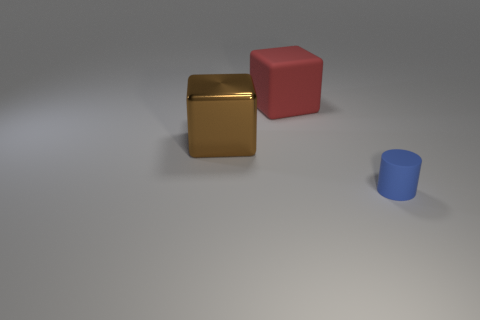Subtract all red blocks. How many blocks are left? 1 Add 2 big things. How many objects exist? 5 Add 2 big red matte blocks. How many big red matte blocks are left? 3 Add 1 yellow blocks. How many yellow blocks exist? 1 Subtract 0 cyan spheres. How many objects are left? 3 Subtract all blocks. How many objects are left? 1 Subtract 1 cubes. How many cubes are left? 1 Subtract all purple cylinders. Subtract all brown spheres. How many cylinders are left? 1 Subtract all purple spheres. How many brown cubes are left? 1 Subtract all tiny gray metal objects. Subtract all big brown metallic cubes. How many objects are left? 2 